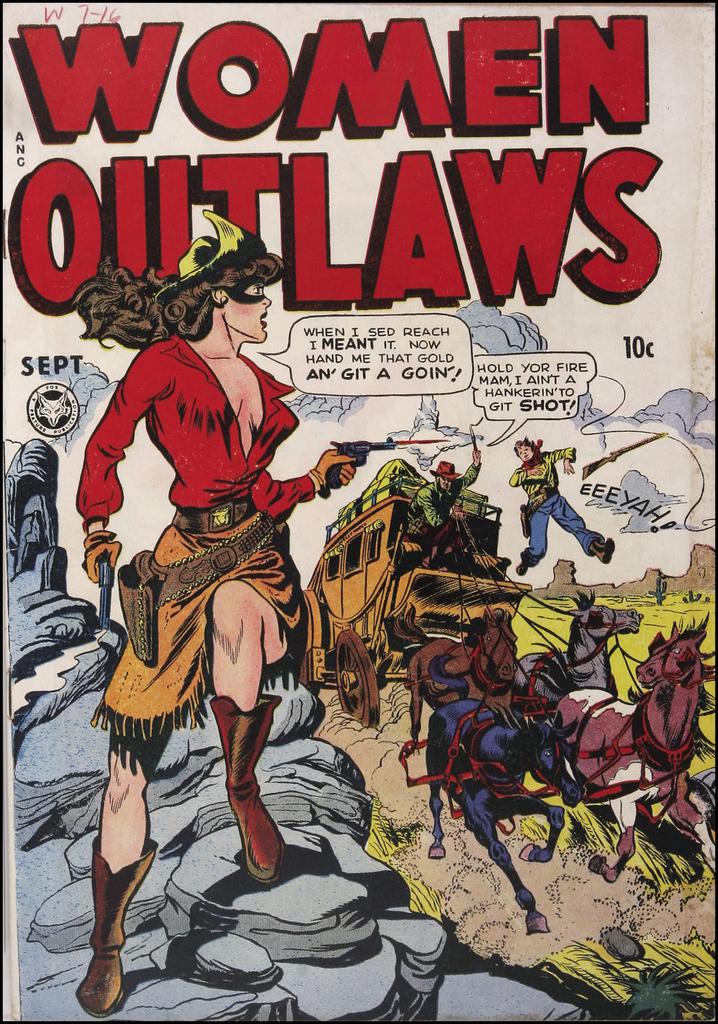What month was this issue published?
Provide a succinct answer. September. 